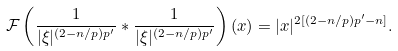<formula> <loc_0><loc_0><loc_500><loc_500>\mathcal { F } \left ( \frac { 1 } { | \xi | ^ { ( 2 - n / p ) p ^ { \prime } } } \ast \frac { 1 } { | \xi | ^ { ( 2 - n / p ) p ^ { \prime } } } \right ) ( x ) = | x | ^ { 2 [ ( 2 - n / p ) p ^ { \prime } - n ] } .</formula> 